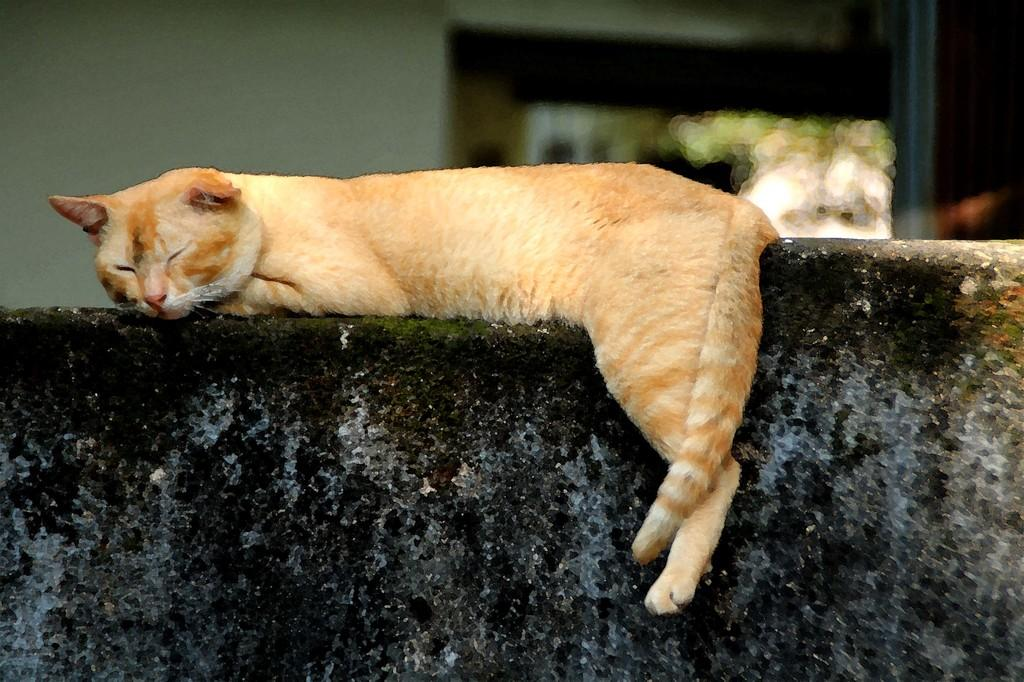What animal can be seen in the image? There is a cat in the image. What is the cat doing in the image? The cat is lying on a wall. How would you describe the background of the image? The background of the image is slightly blurred. What can be seen in the background of the image? There is a wall visible in the background of the image. What type of bells can be heard ringing in the image? There are no bells present in the image, and therefore no sound can be heard. 